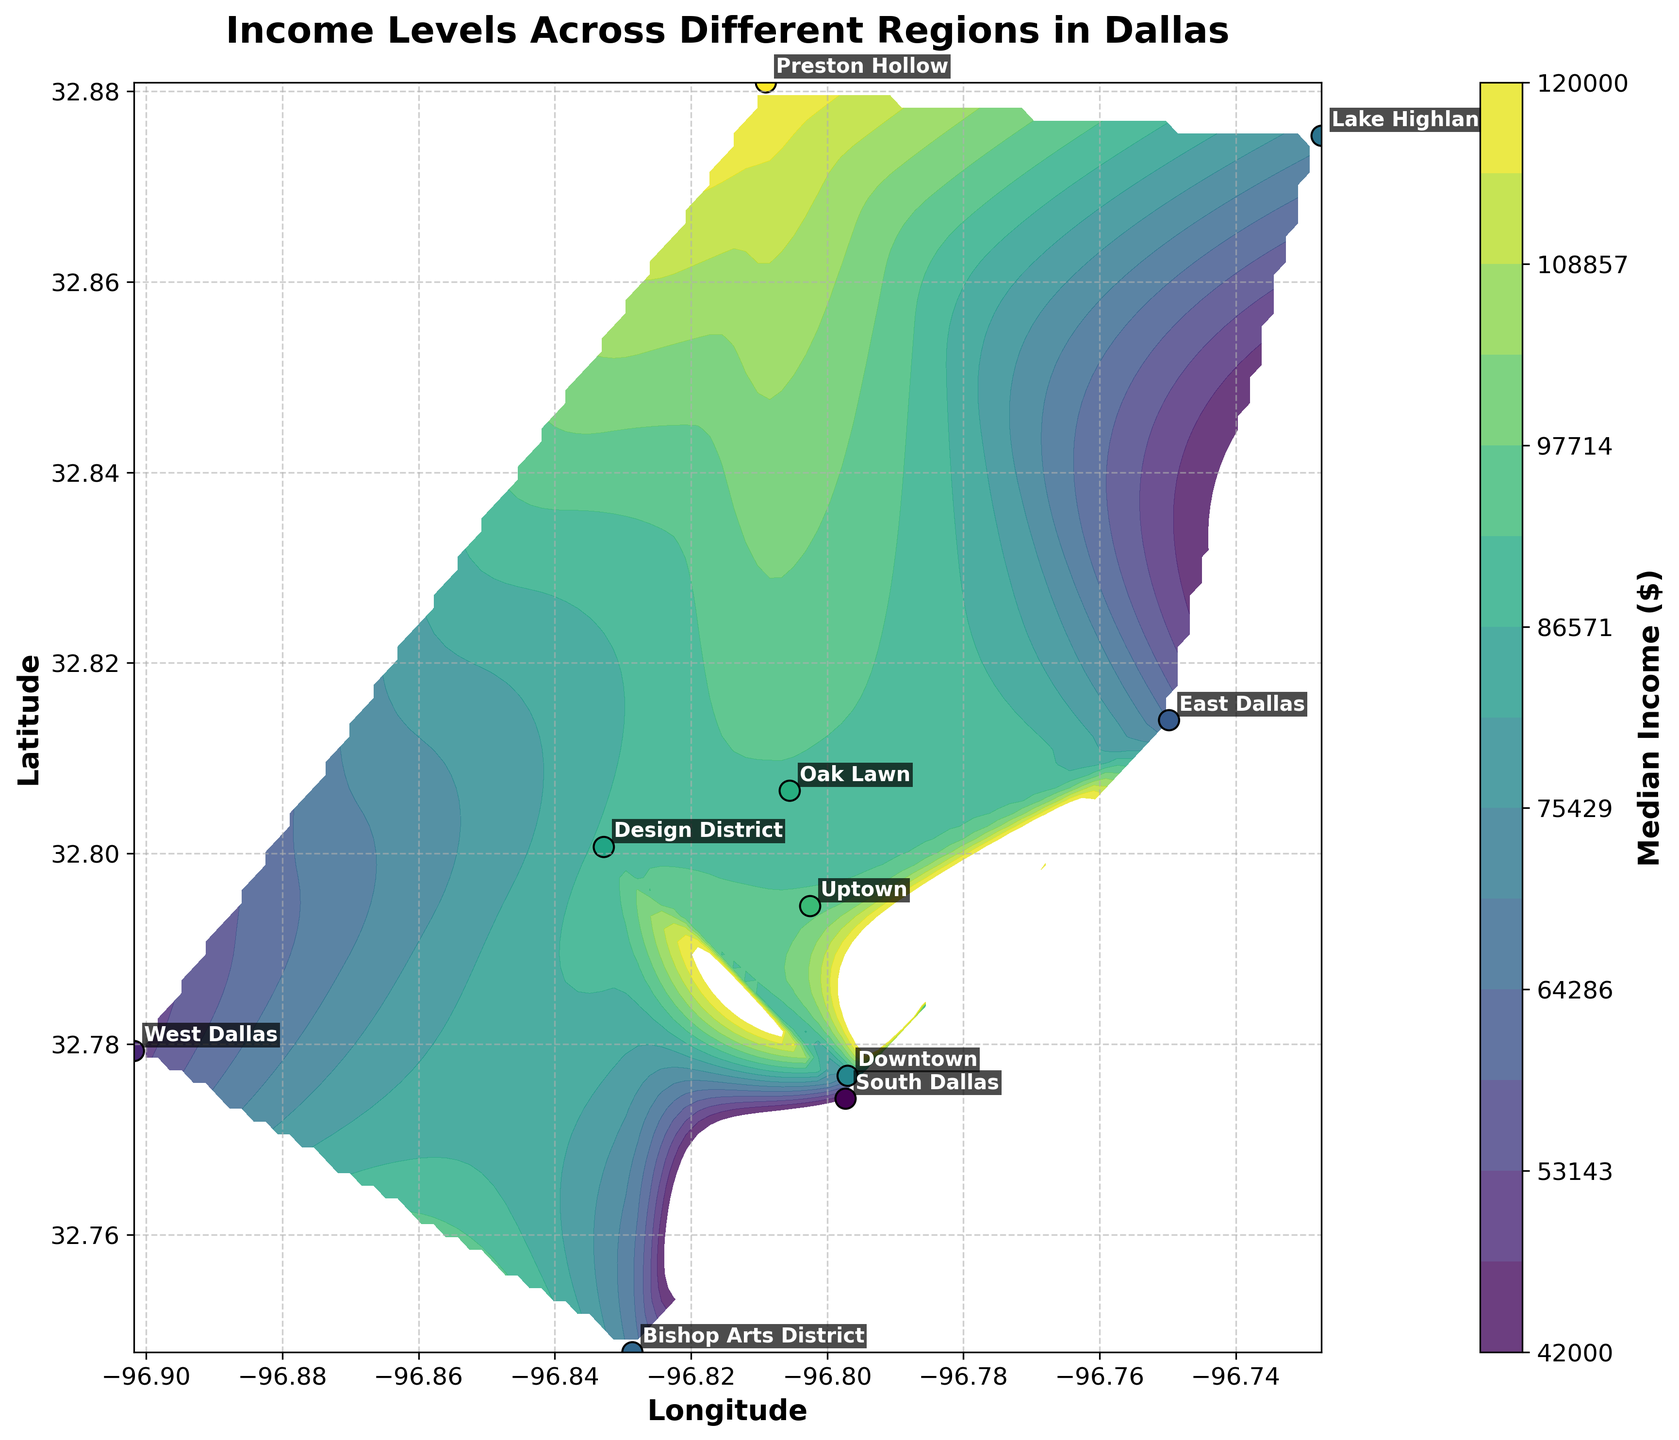What is the title of the plot? The title is displayed at the top of the figure and provides an overview of what the plot represents.
Answer: Income Levels Across Different Regions in Dallas How many data points are plotted on the scatter plot? Count the number of distinct points on the scatter plot.
Answer: 10 Which region has the highest median income? Look for the region with the highest value on the color scale and confirm with the annotations.
Answer: Preston Hollow Which regions have a median income lower than the state average? Identify the color corresponding to the state average income and locate regions with a darker shade, indicating a lower income.
Answer: West Dallas, South Dallas What is the range of median incomes shown on the color bar? Examine the minimum and maximum values labeled on the color bar.
Answer: $42,000 to $120,000 Compare the median income of Uptown and Oak Lawn. Which one is higher? Refer to the specific data points for Uptown and Oak Lawn and compare their colors or values.
Answer: Uptown What is the median income difference between Preston Hollow and South Dallas? Find the median incomes for both regions and subtract the median income of South Dallas from Preston Hollow.
Answer: $78,000 Which region is situated at the northernmost latitude? Locate the data point with the highest latitude value based on the plot's vertical axis.
Answer: Lake Highlands How does the median income in Downtown Dallas compare to the state average? Find Downtown Dallas on the plot and compare its color/intensity to the state average indicated in the plot.
Answer: Higher What pattern do you see regarding income levels as you move from East to West in Dallas? Observe the general trend of colors from the right (East) to left (West) side of the plot.
Answer: Income decreases 